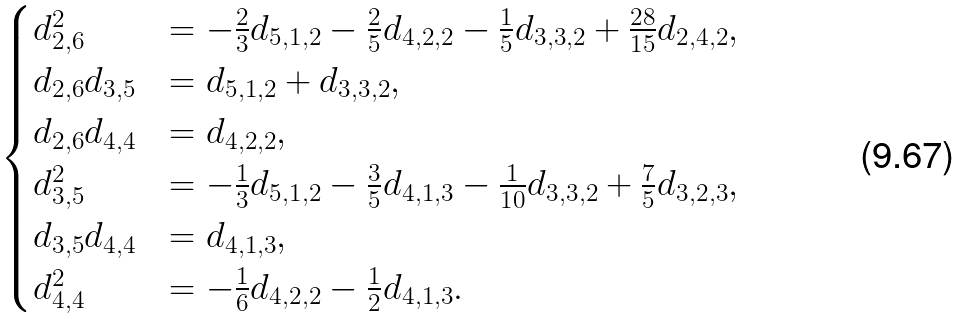<formula> <loc_0><loc_0><loc_500><loc_500>\begin{cases} d _ { 2 , 6 } ^ { 2 } & = - \frac { 2 } { 3 } d _ { 5 , 1 , 2 } - \frac { 2 } { 5 } d _ { 4 , 2 , 2 } - \frac { 1 } { 5 } d _ { 3 , 3 , 2 } + \frac { 2 8 } { 1 5 } d _ { 2 , 4 , 2 } , \\ d _ { 2 , 6 } d _ { 3 , 5 } & = d _ { 5 , 1 , 2 } + d _ { 3 , 3 , 2 } , \\ d _ { 2 , 6 } d _ { 4 , 4 } & = d _ { 4 , 2 , 2 } , \\ d _ { 3 , 5 } ^ { 2 } & = - \frac { 1 } { 3 } d _ { 5 , 1 , 2 } - \frac { 3 } { 5 } d _ { 4 , 1 , 3 } - \frac { 1 } { 1 0 } d _ { 3 , 3 , 2 } + \frac { 7 } { 5 } d _ { 3 , 2 , 3 } , \\ d _ { 3 , 5 } d _ { 4 , 4 } & = d _ { 4 , 1 , 3 } , \\ d _ { 4 , 4 } ^ { 2 } & = - \frac { 1 } { 6 } d _ { 4 , 2 , 2 } - \frac { 1 } { 2 } d _ { 4 , 1 , 3 } . \\ \end{cases}</formula> 